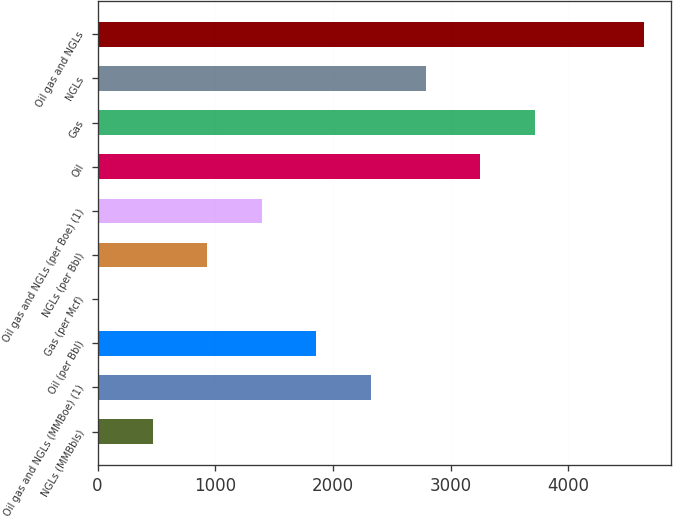Convert chart to OTSL. <chart><loc_0><loc_0><loc_500><loc_500><bar_chart><fcel>NGLs (MMBbls)<fcel>Oil gas and NGLs (MMBoe) (1)<fcel>Oil (per Bbl)<fcel>Gas (per Mcf)<fcel>NGLs (per Bbl)<fcel>Oil gas and NGLs (per Boe) (1)<fcel>Oil<fcel>Gas<fcel>NGLs<fcel>Oil gas and NGLs<nl><fcel>469.09<fcel>2323.73<fcel>1860.07<fcel>5.43<fcel>932.75<fcel>1396.41<fcel>3251.05<fcel>3714.71<fcel>2787.39<fcel>4642<nl></chart> 